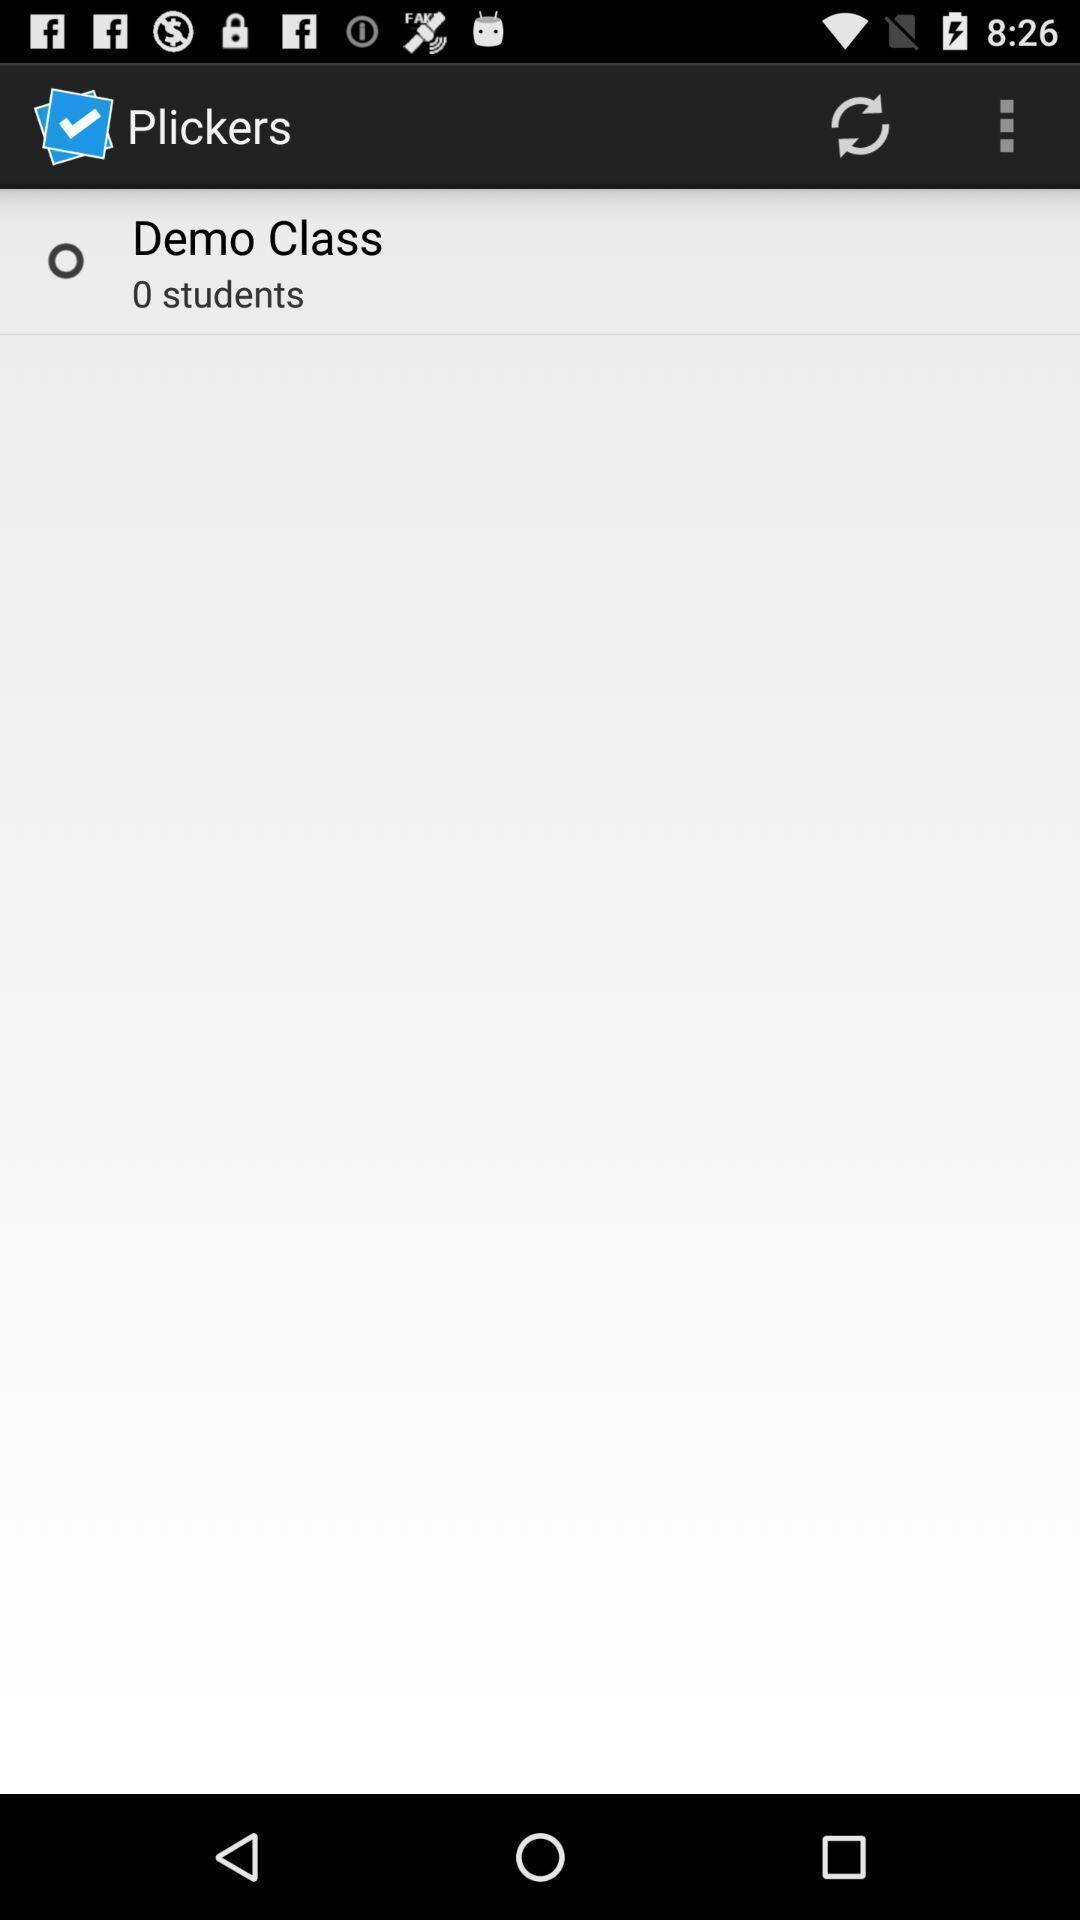Explain the elements present in this screenshot. Window displaying a teaching app. 